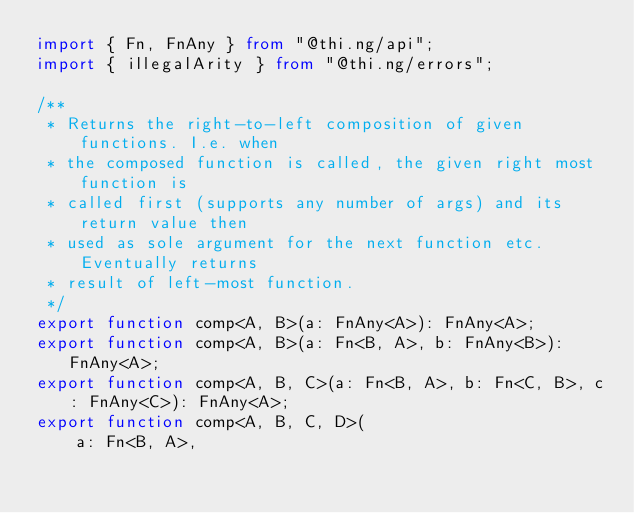Convert code to text. <code><loc_0><loc_0><loc_500><loc_500><_TypeScript_>import { Fn, FnAny } from "@thi.ng/api";
import { illegalArity } from "@thi.ng/errors";

/**
 * Returns the right-to-left composition of given functions. I.e. when
 * the composed function is called, the given right most function is
 * called first (supports any number of args) and its return value then
 * used as sole argument for the next function etc. Eventually returns
 * result of left-most function.
 */
export function comp<A, B>(a: FnAny<A>): FnAny<A>;
export function comp<A, B>(a: Fn<B, A>, b: FnAny<B>): FnAny<A>;
export function comp<A, B, C>(a: Fn<B, A>, b: Fn<C, B>, c: FnAny<C>): FnAny<A>;
export function comp<A, B, C, D>(
    a: Fn<B, A>,</code> 